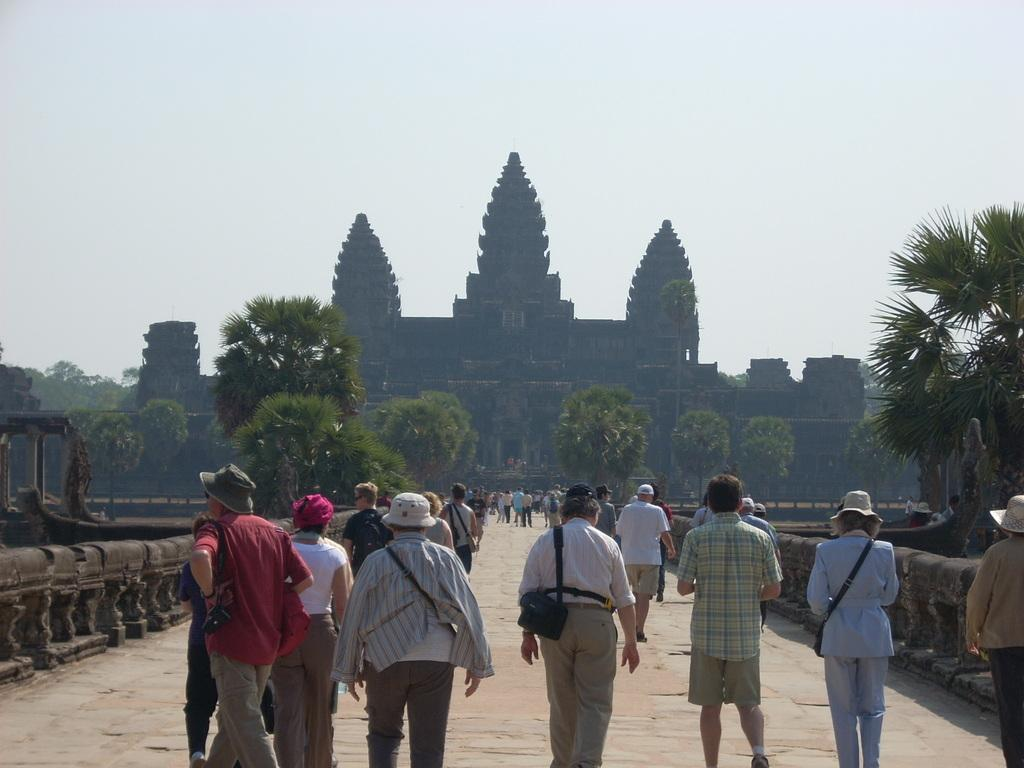How many people are in the image? There is a group of persons in the image. What are the persons in the image doing? The persons are walking on the ground. What is in front of the group of persons? There is a building in front of the group. What type of vegetation can be seen in the image? There are trees in the image. What is visible in the background of the image? The sky is visible in the image. What type of powder can be seen falling from the sky in the image? There is no powder falling from the sky in the image; only the sky is visible. 